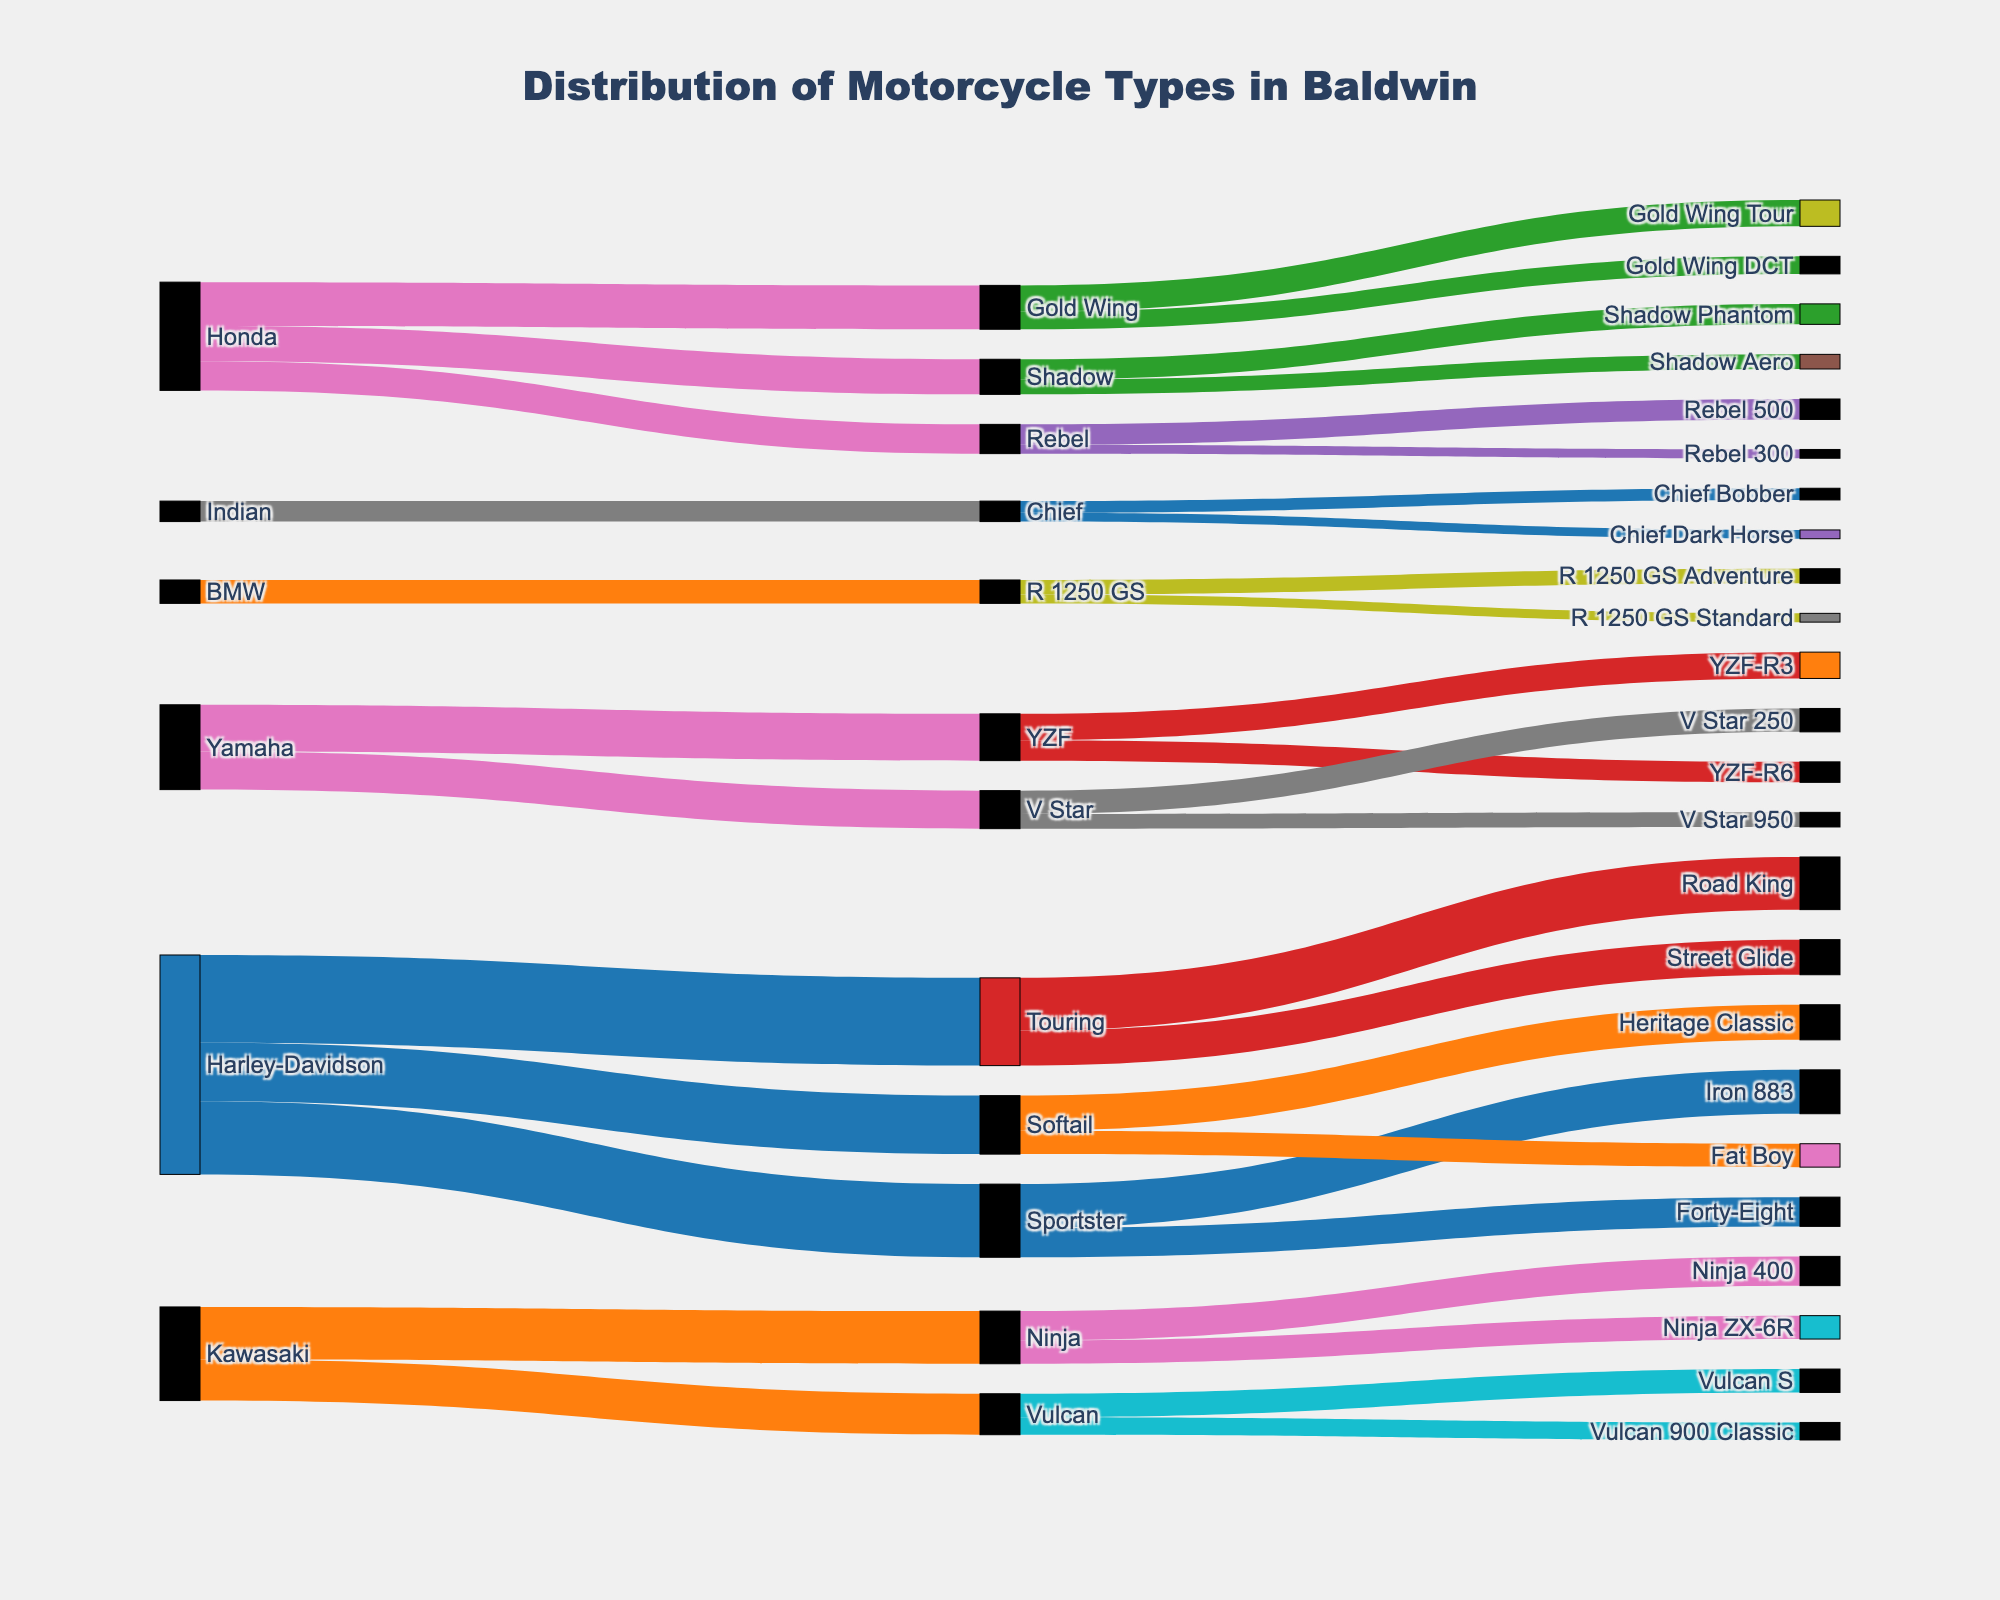What is the total number of Sportster motorcycles distributed? First, locate the Sportster node. Look at the values flowing into the Sportster: Iron 883 (15) and Forty-Eight (10). Sum these values: 15 + 10 = 25.
Answer: 25 Which manufacturer has the highest number of motorcycles distributed? Look for the manufacturers and sum their distributed motorcycles: Harley-Davidson (75), Honda (37), Kawasaki (32), Yamaha (29), BMW (8), Indian (7). Harley-Davidson has the highest with 75 motorcycles.
Answer: Harley-Davidson What is the total number of motorcycles distributed by Yamaha? Identify the Yamaha node and sum the values flowing from it: YZF (16) and V Star (13). Sum these values: 16 + 13 = 29.
Answer: 29 Between the Vulcan S and the Vulcan 900 Classic, which model has more motorcycles? Locate the Vulcan node and see the values flowing to Vulcan S (8) and Vulcan 900 Classic (6). 8 is greater than 6, so Vulcan S has more motorcycles.
Answer: Vulcan S How many motorcyles are distributed by Indian? Look for the Indian node and count the models distributed from it: Chief Bobber (4) and Chief Dark Horse (3). Sum these values: 4 + 3 = 7.
Answer: 7 What is the combined number of motorcycles of BMW and Indian? Find and sum the motorcycles from BMW (8) and Indian (7). Thus, 8 + 7 = 15.
Answer: 15 What’s the most popular specific model from Harley-Davidson? Look at the final nodes for Harley-Davidson's models: Iron 883 (15), Forty-Eight (10), Road King (18), Street Glide (12), Heritage Classic (12), Fat Boy (8). Road King has the highest distribution with 18.
Answer: Road King Compare the number of Rebel 500 to Shadow Phantom. Which has more and by how much? Find the Rebel 500 (7) and Shadow Phantom (7), then calculate the difference: 7 - 7 = 0. They have an equal number of motorcycles.
Answer: Equal, 0 Among the YZF models, how many more YZF-R3 motorcycles are there compared to YZF-R6? Locate YZF-R3 (9) and YZF-R6 (7), and find the difference: 9 - 7 = 2. There are 2 more YZF-R3 motorcycles.
Answer: 2 What is the least distributed specific model among Baldwin riders? Look at all the target nodes with their values and find the minimum value, which is Rebel 300 with 3 motorcycles.
Answer: Rebel 300 